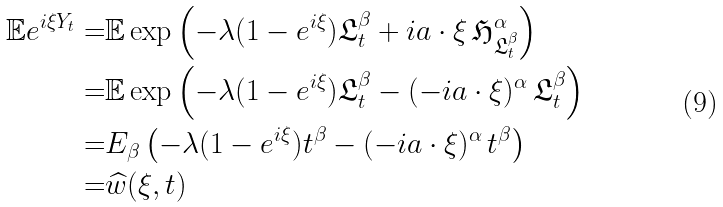<formula> <loc_0><loc_0><loc_500><loc_500>\mathbb { E } e ^ { i \xi Y _ { t } } = & \mathbb { E } \exp \left ( - \lambda ( 1 - e ^ { i \xi } ) \mathfrak { L } ^ { \beta } _ { t } + i a \cdot \xi \, \mathfrak { H } ^ { \alpha } _ { \mathfrak { L } ^ { \beta } _ { t } } \right ) \\ = & \mathbb { E } \exp \left ( - \lambda ( 1 - e ^ { i \xi } ) \mathfrak { L } ^ { \beta } _ { t } - ( - i a \cdot \xi ) ^ { \alpha } \, \mathfrak { L } ^ { \beta } _ { t } \right ) \\ = & E _ { \beta } \left ( - \lambda ( 1 - e ^ { i \xi } ) t ^ { \beta } - ( - i a \cdot \xi ) ^ { \alpha } \, t ^ { \beta } \right ) \\ = & \widehat { w } ( \xi , t )</formula> 